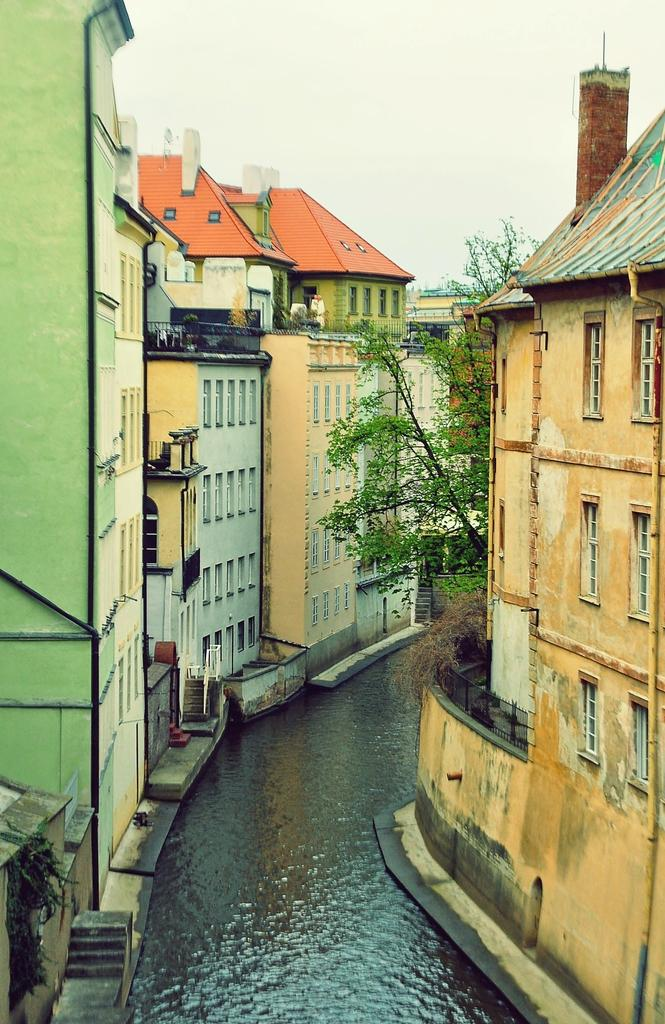What type of natural feature is visible in the image? There is a lake in the image. What structures can be seen near the lake? Buildings are present on both sides of the lake. What is located in the middle of the image? There is a tree in the middle of the image. What is the color of the sky in the image? The sky is white in color. How many rabbits can be seen hopping around the tree in the image? There are no rabbits present in the image; it only features a tree, a lake, and buildings. What type of trade is taking place near the lake in the image? There is no trade taking place in the image; it only shows a lake, buildings, and a tree. 